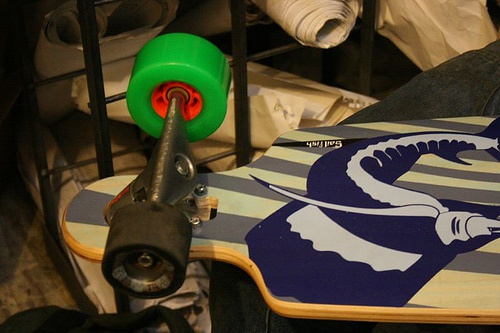Describe the objects in this image and their specific colors. I can see a skateboard in black, gray, darkgray, and tan tones in this image. 